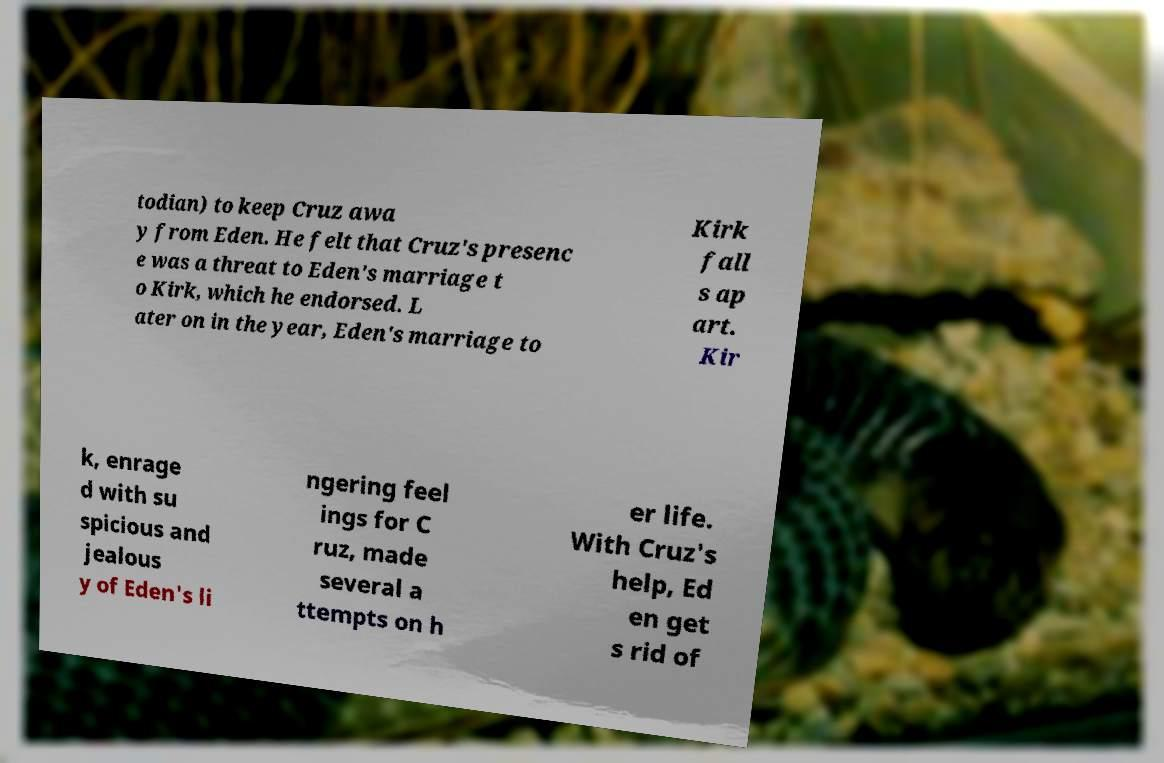Could you assist in decoding the text presented in this image and type it out clearly? todian) to keep Cruz awa y from Eden. He felt that Cruz's presenc e was a threat to Eden's marriage t o Kirk, which he endorsed. L ater on in the year, Eden's marriage to Kirk fall s ap art. Kir k, enrage d with su spicious and jealous y of Eden's li ngering feel ings for C ruz, made several a ttempts on h er life. With Cruz's help, Ed en get s rid of 